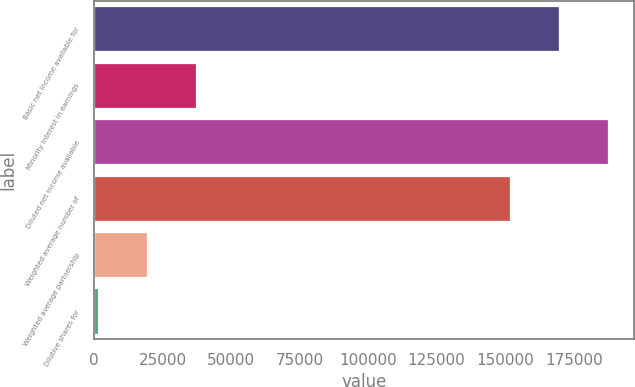Convert chart to OTSL. <chart><loc_0><loc_0><loc_500><loc_500><bar_chart><fcel>Basic net income available for<fcel>Minority interest in earnings<fcel>Diluted net income available<fcel>Weighted average number of<fcel>Weighted average partnership<fcel>Dilutive shares for<nl><fcel>169666<fcel>37100.8<fcel>187508<fcel>151823<fcel>19258.4<fcel>1416<nl></chart> 